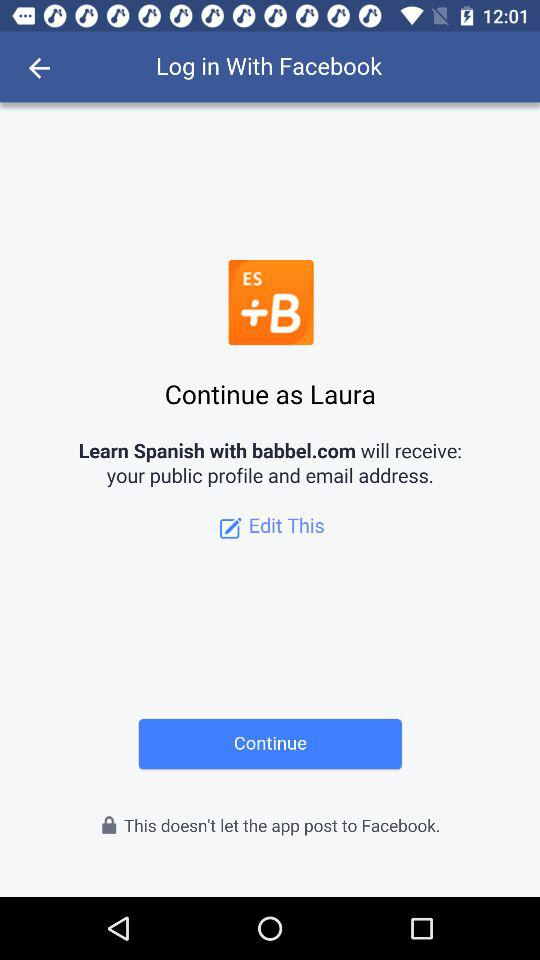What is the user name with which the profile can be continued? The user name with which the profile can be continued is Laura. 